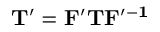Convert formula to latex. <formula><loc_0><loc_0><loc_500><loc_500>T ^ { \prime } = F ^ { \prime } T F ^ { \prime - 1 }</formula> 